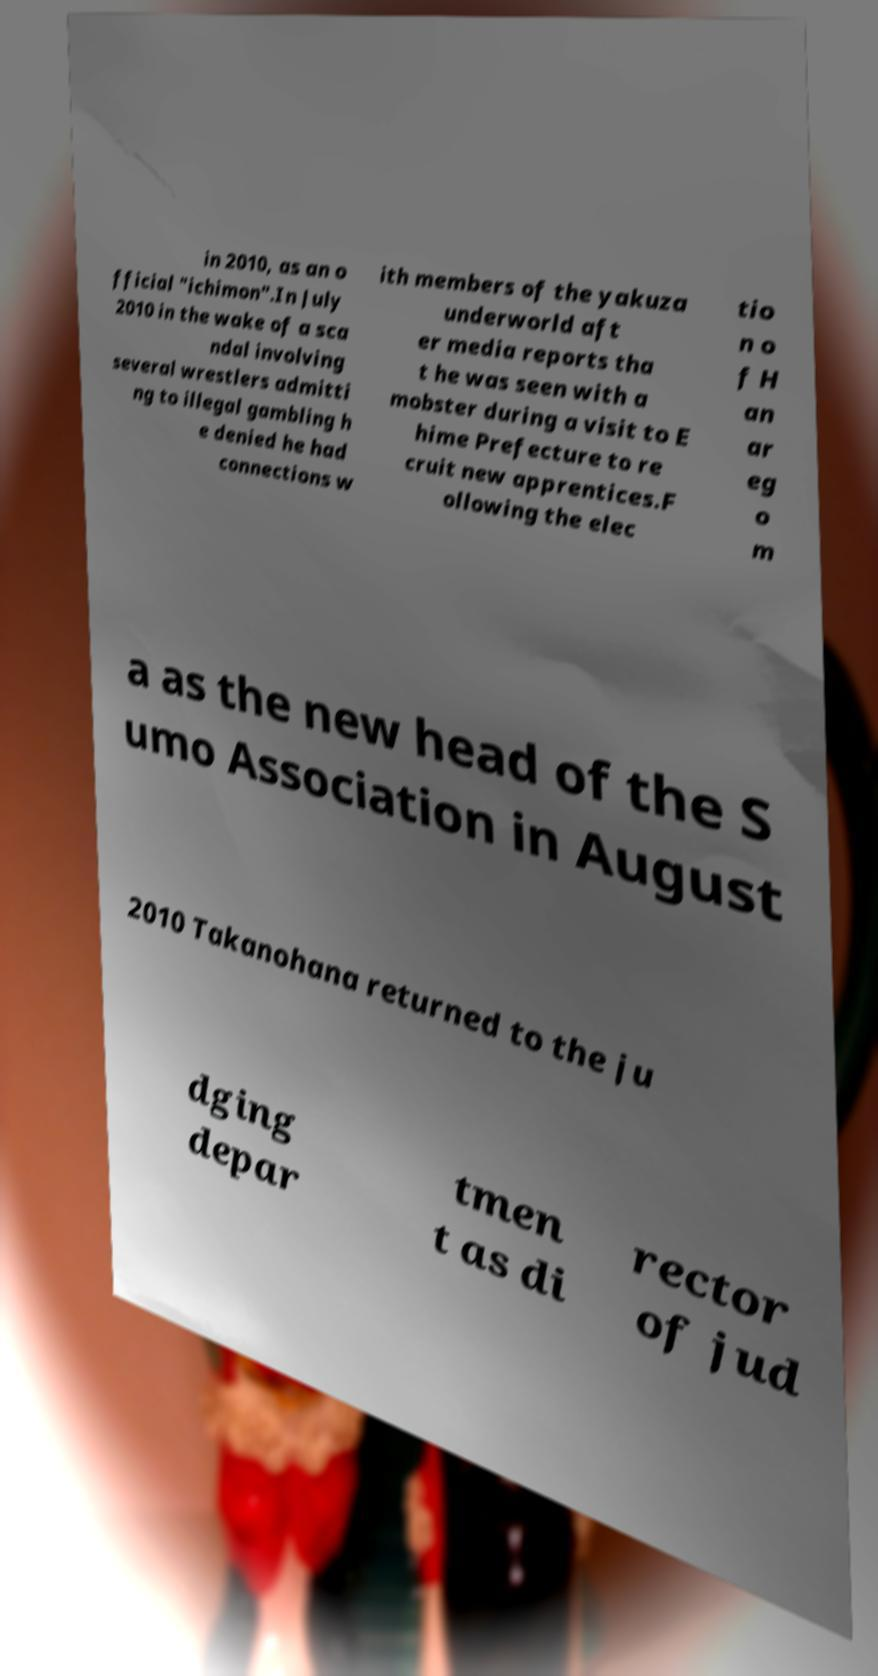Please read and relay the text visible in this image. What does it say? in 2010, as an o fficial "ichimon".In July 2010 in the wake of a sca ndal involving several wrestlers admitti ng to illegal gambling h e denied he had connections w ith members of the yakuza underworld aft er media reports tha t he was seen with a mobster during a visit to E hime Prefecture to re cruit new apprentices.F ollowing the elec tio n o f H an ar eg o m a as the new head of the S umo Association in August 2010 Takanohana returned to the ju dging depar tmen t as di rector of jud 